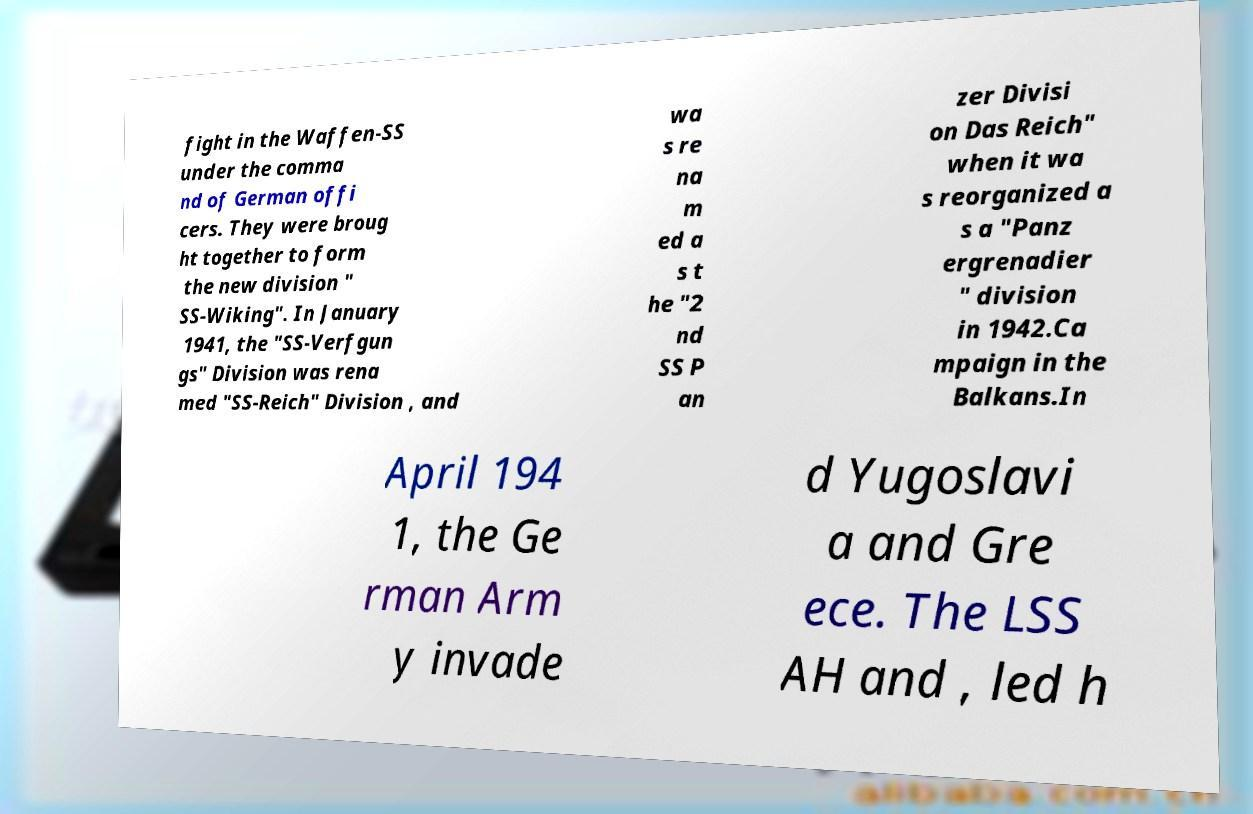Could you assist in decoding the text presented in this image and type it out clearly? fight in the Waffen-SS under the comma nd of German offi cers. They were broug ht together to form the new division " SS-Wiking". In January 1941, the "SS-Verfgun gs" Division was rena med "SS-Reich" Division , and wa s re na m ed a s t he "2 nd SS P an zer Divisi on Das Reich" when it wa s reorganized a s a "Panz ergrenadier " division in 1942.Ca mpaign in the Balkans.In April 194 1, the Ge rman Arm y invade d Yugoslavi a and Gre ece. The LSS AH and , led h 